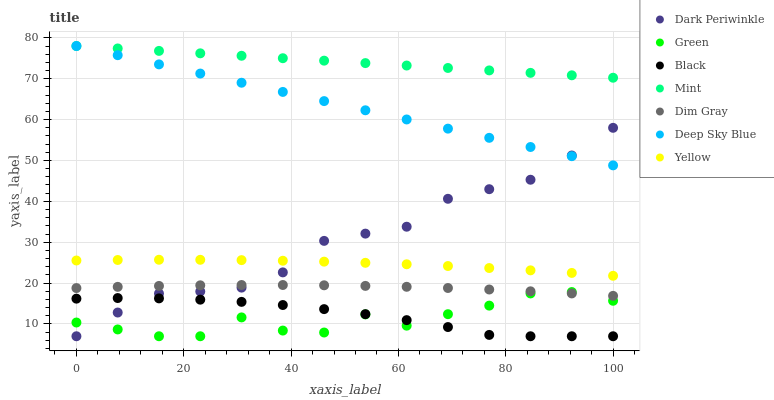Does Green have the minimum area under the curve?
Answer yes or no. Yes. Does Mint have the maximum area under the curve?
Answer yes or no. Yes. Does Yellow have the minimum area under the curve?
Answer yes or no. No. Does Yellow have the maximum area under the curve?
Answer yes or no. No. Is Deep Sky Blue the smoothest?
Answer yes or no. Yes. Is Green the roughest?
Answer yes or no. Yes. Is Yellow the smoothest?
Answer yes or no. No. Is Yellow the roughest?
Answer yes or no. No. Does Black have the lowest value?
Answer yes or no. Yes. Does Yellow have the lowest value?
Answer yes or no. No. Does Mint have the highest value?
Answer yes or no. Yes. Does Yellow have the highest value?
Answer yes or no. No. Is Green less than Yellow?
Answer yes or no. Yes. Is Yellow greater than Green?
Answer yes or no. Yes. Does Dim Gray intersect Dark Periwinkle?
Answer yes or no. Yes. Is Dim Gray less than Dark Periwinkle?
Answer yes or no. No. Is Dim Gray greater than Dark Periwinkle?
Answer yes or no. No. Does Green intersect Yellow?
Answer yes or no. No. 